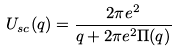Convert formula to latex. <formula><loc_0><loc_0><loc_500><loc_500>U _ { s c } ( q ) = \frac { 2 \pi e ^ { 2 } } { q + 2 \pi e ^ { 2 } \Pi ( q ) }</formula> 